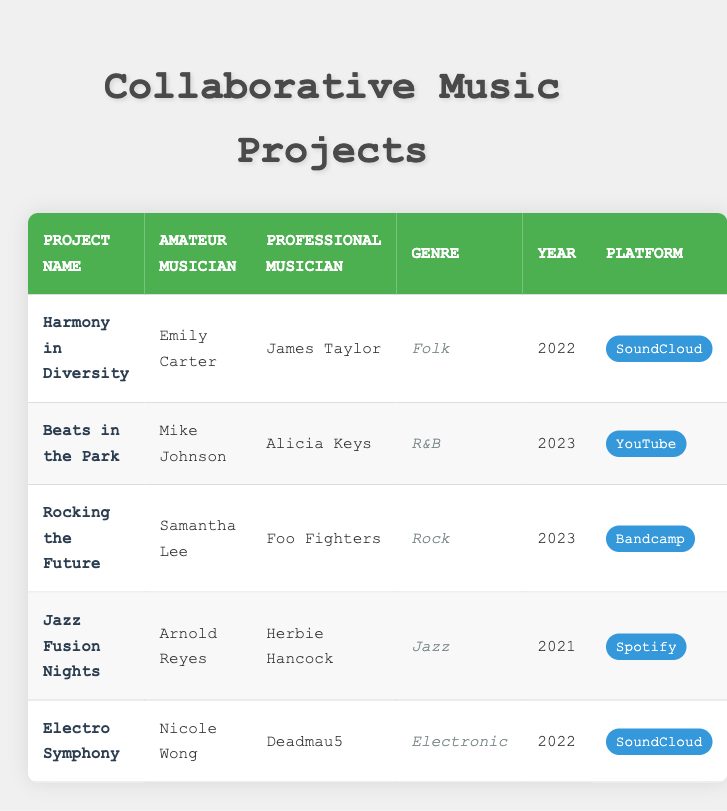What is the genre of the project "Electro Symphony"? The table indicates that the project "Electro Symphony" is categorized under the genre "Electronic." This information can be found in the corresponding row for this project.
Answer: Electronic Who collaborated with Arnold Reyes on the project "Jazz Fusion Nights"? The table shows that Arnold Reyes collaborated with professional musician Herbie Hancock on the project "Jazz Fusion Nights." This can be seen in the row detailing this project.
Answer: Herbie Hancock How many projects were released in 2023? By examining the table, I see that there are two projects listed in the year 2023: "Beats in the Park" and "Rocking the Future." Hence, the count is 2.
Answer: 2 Did any projects utilize Bandcamp as their platform? Looking at the table, it lists the project "Rocking the Future" as being on the platform Bandcamp. Therefore, the answer to this question is yes.
Answer: Yes Which professional musician worked with the most recent amateur musician? In the table, the most recent amateur musician is Mike Johnson (2023) who collaborated with Alicia Keys on the project "Beats in the Park." This is determined by the year listed next to each project.
Answer: Alicia Keys What is the average year of the projects listed? The years of the projects are 2022, 2023, 2023, 2021, and 2022. To find the average, add these years: 2022 + 2023 + 2023 + 2021 + 2022 = 1011. There are 5 projects, so the average year is 1011 / 5 = 202.2, which rounds to 2022.
Answer: 2022 Is there a project in the genre "Folk" released in 2022? The table indicates that the project "Harmony in Diversity" has the genre of "Folk" and was released in the year 2022. Therefore, the answer is yes.
Answer: Yes How many unique genres are represented in the projects? The genres listed are Folk, R&B, Rock, Jazz, and Electronic. Counting these, we find there are 5 unique genres represented in the projects.
Answer: 5 What is the name of the amateur musician who collaborated with Deadmau5? The table lists Nicole Wong as the amateur musician who collaborated with Deadmau5 on the project "Electro Symphony." This is clearly defined in the respective row for that project.
Answer: Nicole Wong 